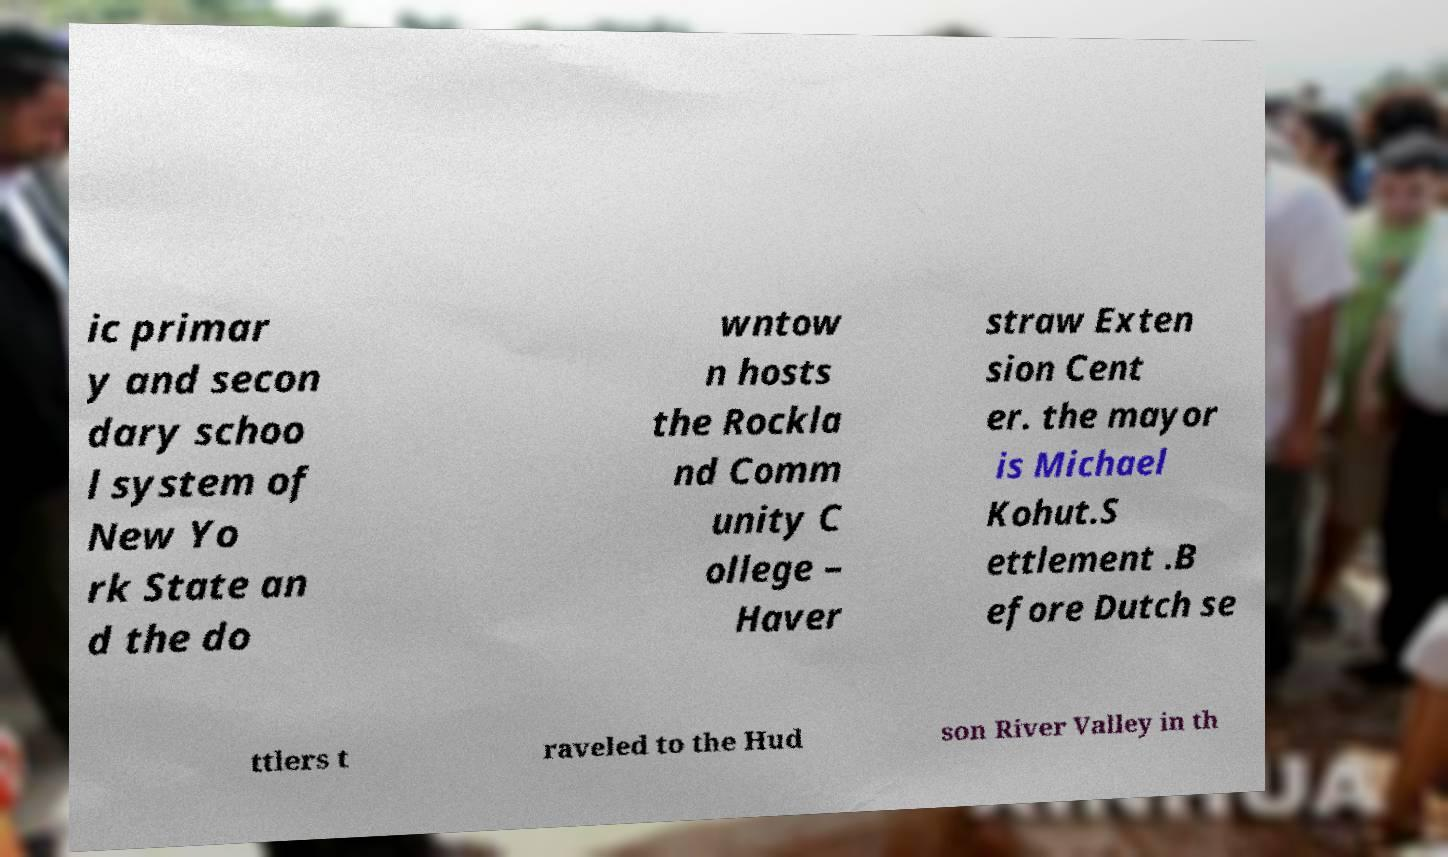Could you extract and type out the text from this image? ic primar y and secon dary schoo l system of New Yo rk State an d the do wntow n hosts the Rockla nd Comm unity C ollege – Haver straw Exten sion Cent er. the mayor is Michael Kohut.S ettlement .B efore Dutch se ttlers t raveled to the Hud son River Valley in th 